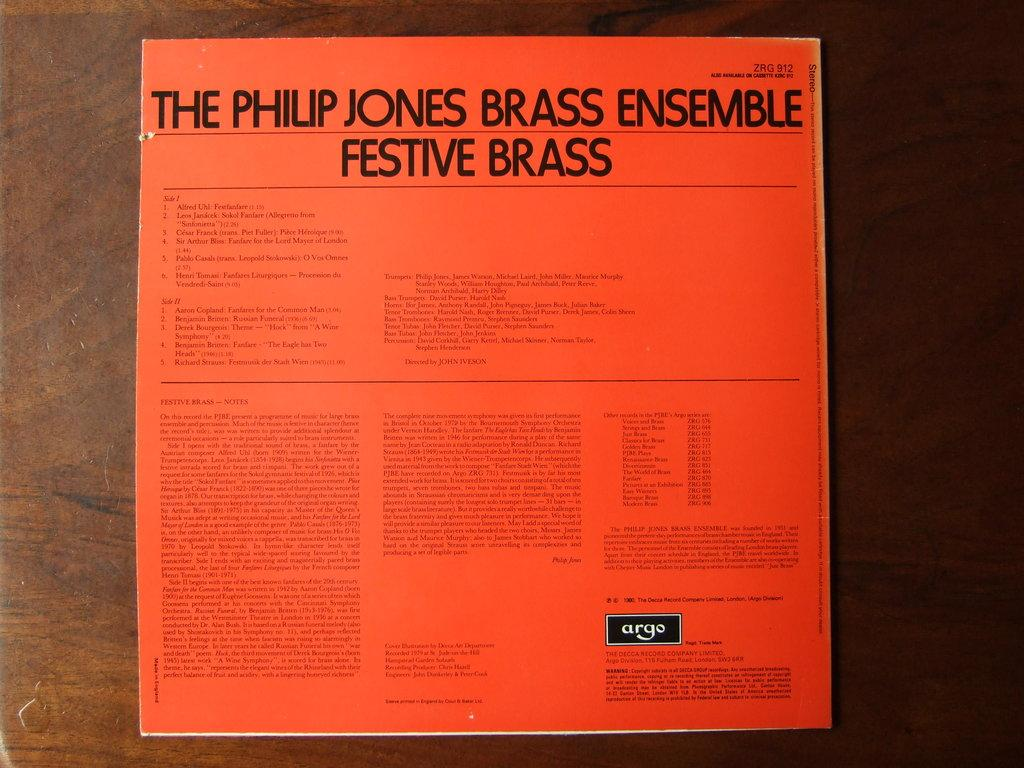<image>
Offer a succinct explanation of the picture presented. Orange album cover that says "The Philip Jones Brass Ensemble Festive Brass". 